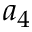Convert formula to latex. <formula><loc_0><loc_0><loc_500><loc_500>a _ { 4 }</formula> 